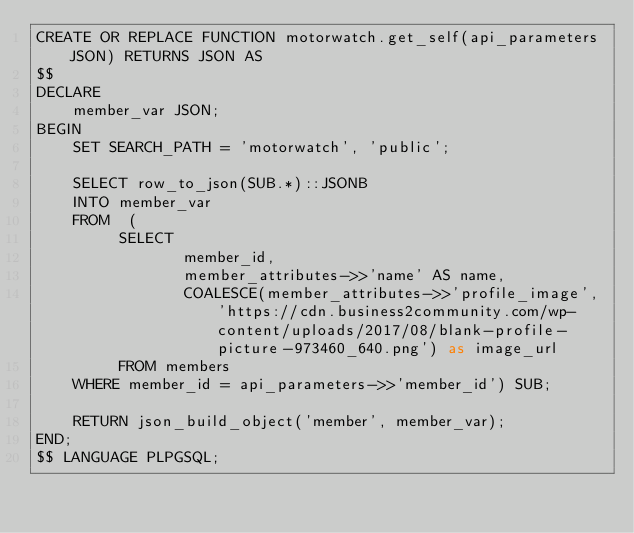<code> <loc_0><loc_0><loc_500><loc_500><_SQL_>CREATE OR REPLACE FUNCTION motorwatch.get_self(api_parameters JSON) RETURNS JSON AS
$$
DECLARE
    member_var JSON;
BEGIN
    SET SEARCH_PATH = 'motorwatch', 'public';

    SELECT row_to_json(SUB.*)::JSONB
    INTO member_var
    FROM  (
         SELECT
                member_id,
                member_attributes->>'name' AS name,
                COALESCE(member_attributes->>'profile_image', 'https://cdn.business2community.com/wp-content/uploads/2017/08/blank-profile-picture-973460_640.png') as image_url
         FROM members
    WHERE member_id = api_parameters->>'member_id') SUB;

    RETURN json_build_object('member', member_var);
END;
$$ LANGUAGE PLPGSQL;
</code> 